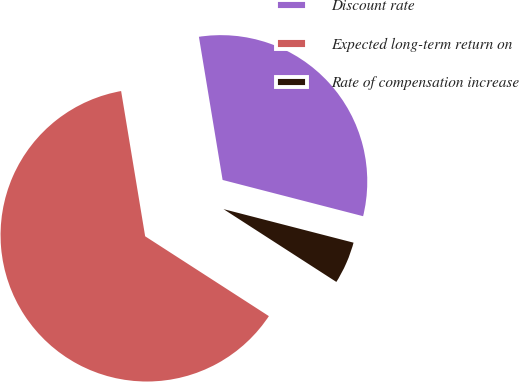<chart> <loc_0><loc_0><loc_500><loc_500><pie_chart><fcel>Discount rate<fcel>Expected long-term return on<fcel>Rate of compensation increase<nl><fcel>31.63%<fcel>63.27%<fcel>5.1%<nl></chart> 